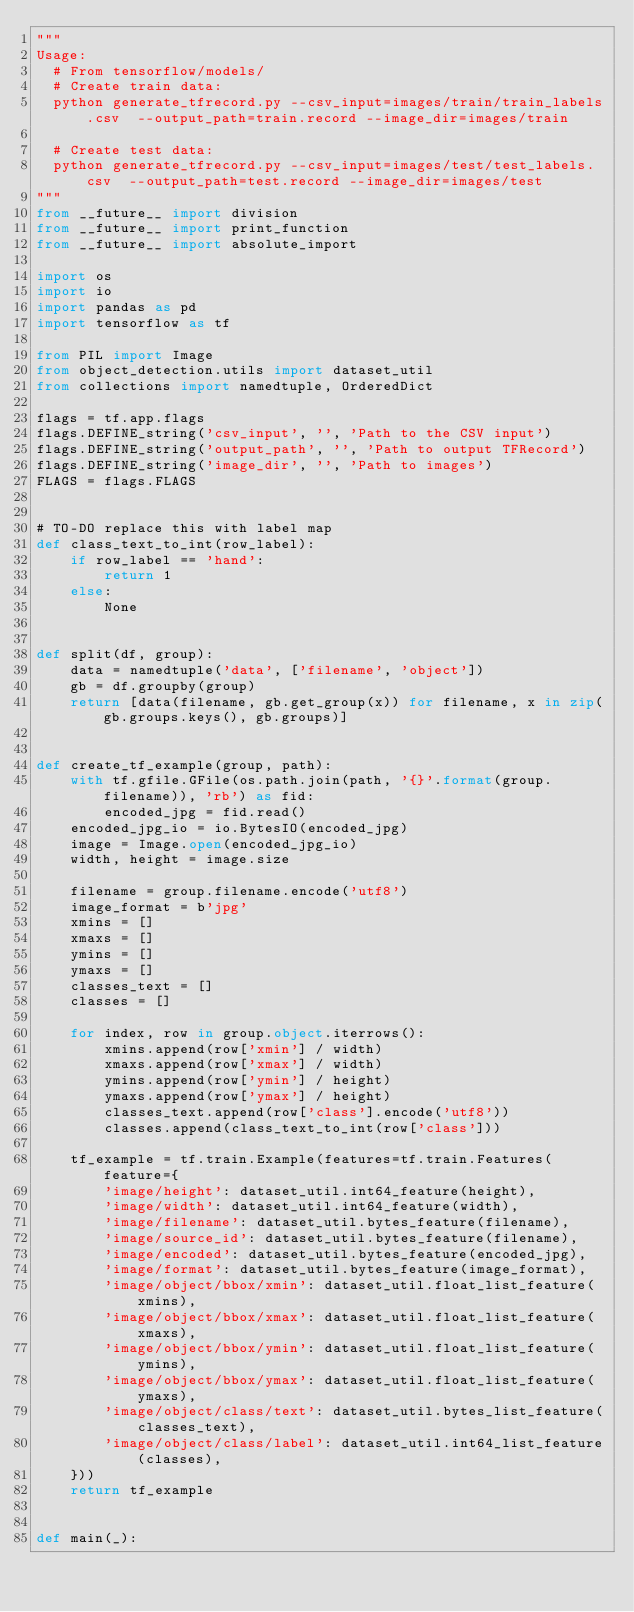<code> <loc_0><loc_0><loc_500><loc_500><_Python_>"""
Usage:
  # From tensorflow/models/
  # Create train data:
  python generate_tfrecord.py --csv_input=images/train/train_labels.csv  --output_path=train.record --image_dir=images/train

  # Create test data:
  python generate_tfrecord.py --csv_input=images/test/test_labels.csv  --output_path=test.record --image_dir=images/test
"""
from __future__ import division
from __future__ import print_function
from __future__ import absolute_import

import os
import io
import pandas as pd
import tensorflow as tf

from PIL import Image
from object_detection.utils import dataset_util
from collections import namedtuple, OrderedDict

flags = tf.app.flags
flags.DEFINE_string('csv_input', '', 'Path to the CSV input')
flags.DEFINE_string('output_path', '', 'Path to output TFRecord')
flags.DEFINE_string('image_dir', '', 'Path to images')
FLAGS = flags.FLAGS


# TO-DO replace this with label map
def class_text_to_int(row_label):
    if row_label == 'hand':
        return 1
    else:
        None


def split(df, group):
    data = namedtuple('data', ['filename', 'object'])
    gb = df.groupby(group)
    return [data(filename, gb.get_group(x)) for filename, x in zip(gb.groups.keys(), gb.groups)]


def create_tf_example(group, path):
    with tf.gfile.GFile(os.path.join(path, '{}'.format(group.filename)), 'rb') as fid:
        encoded_jpg = fid.read()
    encoded_jpg_io = io.BytesIO(encoded_jpg)
    image = Image.open(encoded_jpg_io)
    width, height = image.size

    filename = group.filename.encode('utf8')
    image_format = b'jpg'
    xmins = []
    xmaxs = []
    ymins = []
    ymaxs = []
    classes_text = []
    classes = []

    for index, row in group.object.iterrows():
        xmins.append(row['xmin'] / width)
        xmaxs.append(row['xmax'] / width)
        ymins.append(row['ymin'] / height)
        ymaxs.append(row['ymax'] / height)
        classes_text.append(row['class'].encode('utf8'))
        classes.append(class_text_to_int(row['class']))

    tf_example = tf.train.Example(features=tf.train.Features(feature={
        'image/height': dataset_util.int64_feature(height),
        'image/width': dataset_util.int64_feature(width),
        'image/filename': dataset_util.bytes_feature(filename),
        'image/source_id': dataset_util.bytes_feature(filename),
        'image/encoded': dataset_util.bytes_feature(encoded_jpg),
        'image/format': dataset_util.bytes_feature(image_format),
        'image/object/bbox/xmin': dataset_util.float_list_feature(xmins),
        'image/object/bbox/xmax': dataset_util.float_list_feature(xmaxs),
        'image/object/bbox/ymin': dataset_util.float_list_feature(ymins),
        'image/object/bbox/ymax': dataset_util.float_list_feature(ymaxs),
        'image/object/class/text': dataset_util.bytes_list_feature(classes_text),
        'image/object/class/label': dataset_util.int64_list_feature(classes),
    }))
    return tf_example


def main(_):</code> 